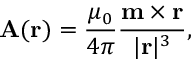<formula> <loc_0><loc_0><loc_500><loc_500>A ( r ) = { \frac { \mu _ { 0 } } { 4 \pi } } { \frac { m \times r } { | r | ^ { 3 } } } ,</formula> 